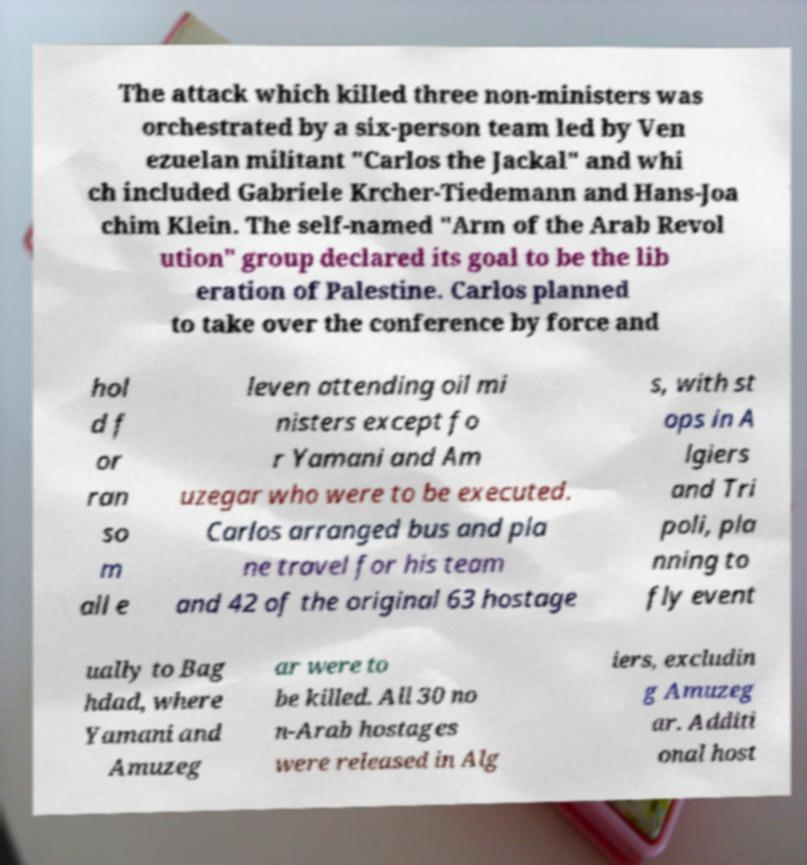For documentation purposes, I need the text within this image transcribed. Could you provide that? The attack which killed three non-ministers was orchestrated by a six-person team led by Ven ezuelan militant "Carlos the Jackal" and whi ch included Gabriele Krcher-Tiedemann and Hans-Joa chim Klein. The self-named "Arm of the Arab Revol ution" group declared its goal to be the lib eration of Palestine. Carlos planned to take over the conference by force and hol d f or ran so m all e leven attending oil mi nisters except fo r Yamani and Am uzegar who were to be executed. Carlos arranged bus and pla ne travel for his team and 42 of the original 63 hostage s, with st ops in A lgiers and Tri poli, pla nning to fly event ually to Bag hdad, where Yamani and Amuzeg ar were to be killed. All 30 no n-Arab hostages were released in Alg iers, excludin g Amuzeg ar. Additi onal host 